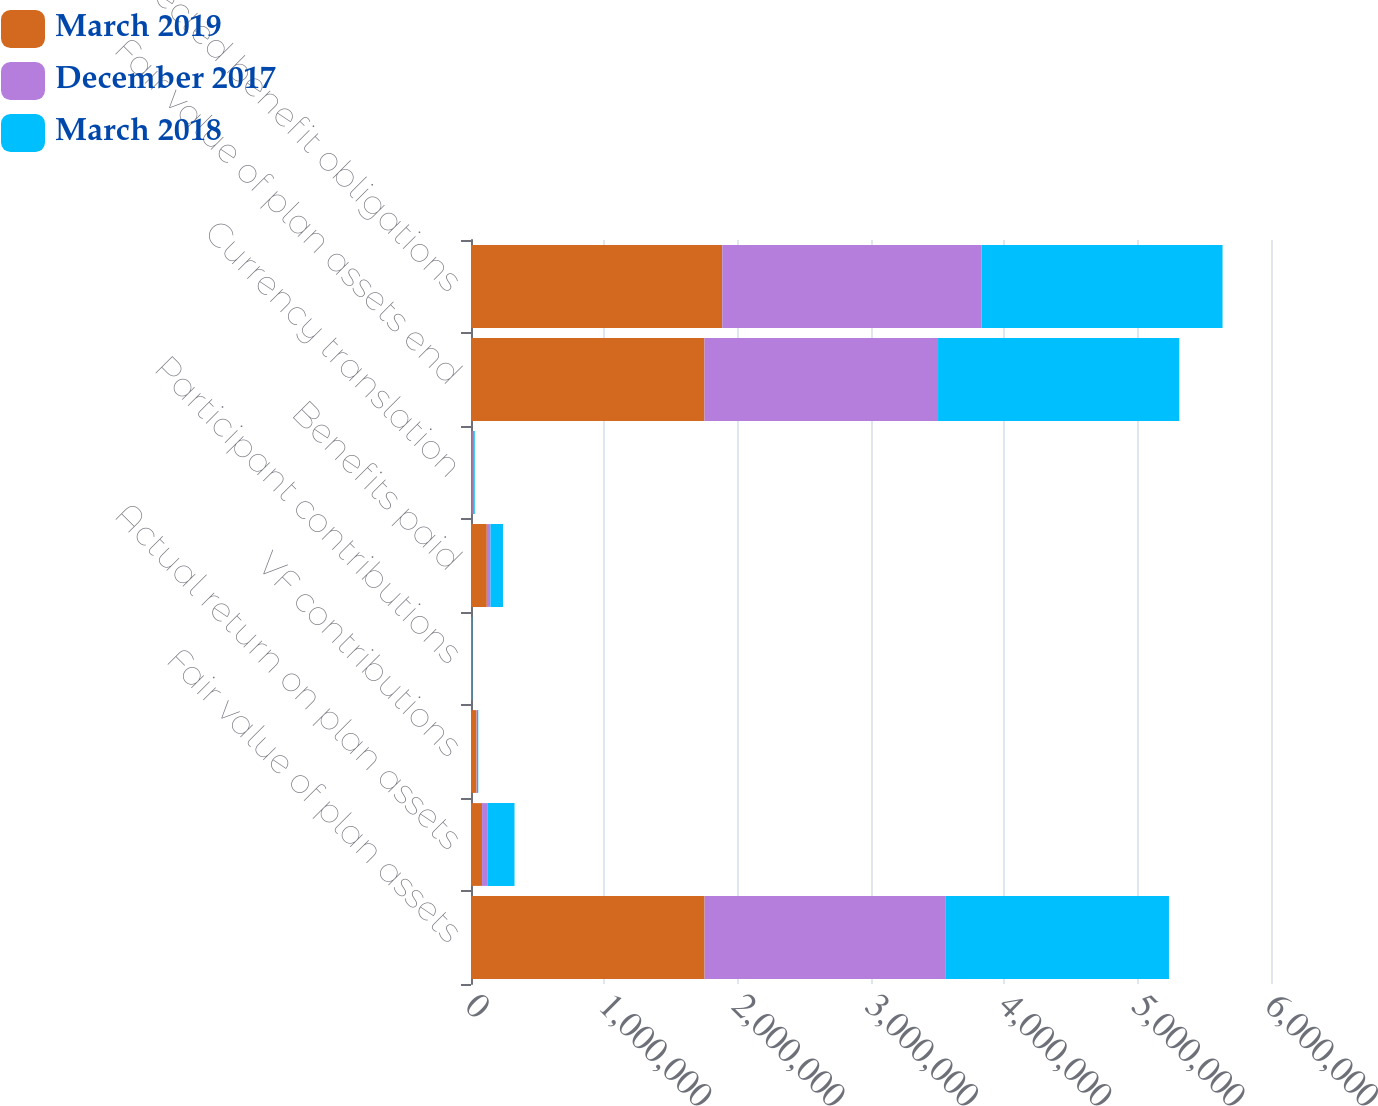Convert chart. <chart><loc_0><loc_0><loc_500><loc_500><stacked_bar_chart><ecel><fcel>Fair value of plan assets<fcel>Actual return on plan assets<fcel>VF contributions<fcel>Participant contributions<fcel>Benefits paid<fcel>Currency translation<fcel>Fair value of plan assets end<fcel>Projected benefit obligations<nl><fcel>March 2019<fcel>1.75176e+06<fcel>82947<fcel>41581<fcel>4136<fcel>118513<fcel>10817<fcel>1.75109e+06<fcel>1.88448e+06<nl><fcel>December 2017<fcel>1.80965e+06<fcel>39495<fcel>3205<fcel>1018<fcel>27441<fcel>4824<fcel>1.75176e+06<fcel>1.94382e+06<nl><fcel>March 2018<fcel>1.6733e+06<fcel>204017<fcel>9807<fcel>4011<fcel>93900<fcel>12417<fcel>1.80965e+06<fcel>1.80833e+06<nl></chart> 